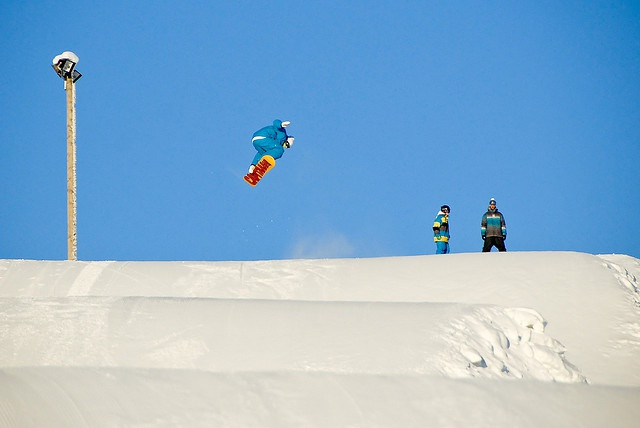Describe the objects in this image and their specific colors. I can see people in gray, teal, and lightblue tones, people in gray, black, and teal tones, people in gray, black, teal, and lightblue tones, and snowboard in gray, brown, orange, and red tones in this image. 